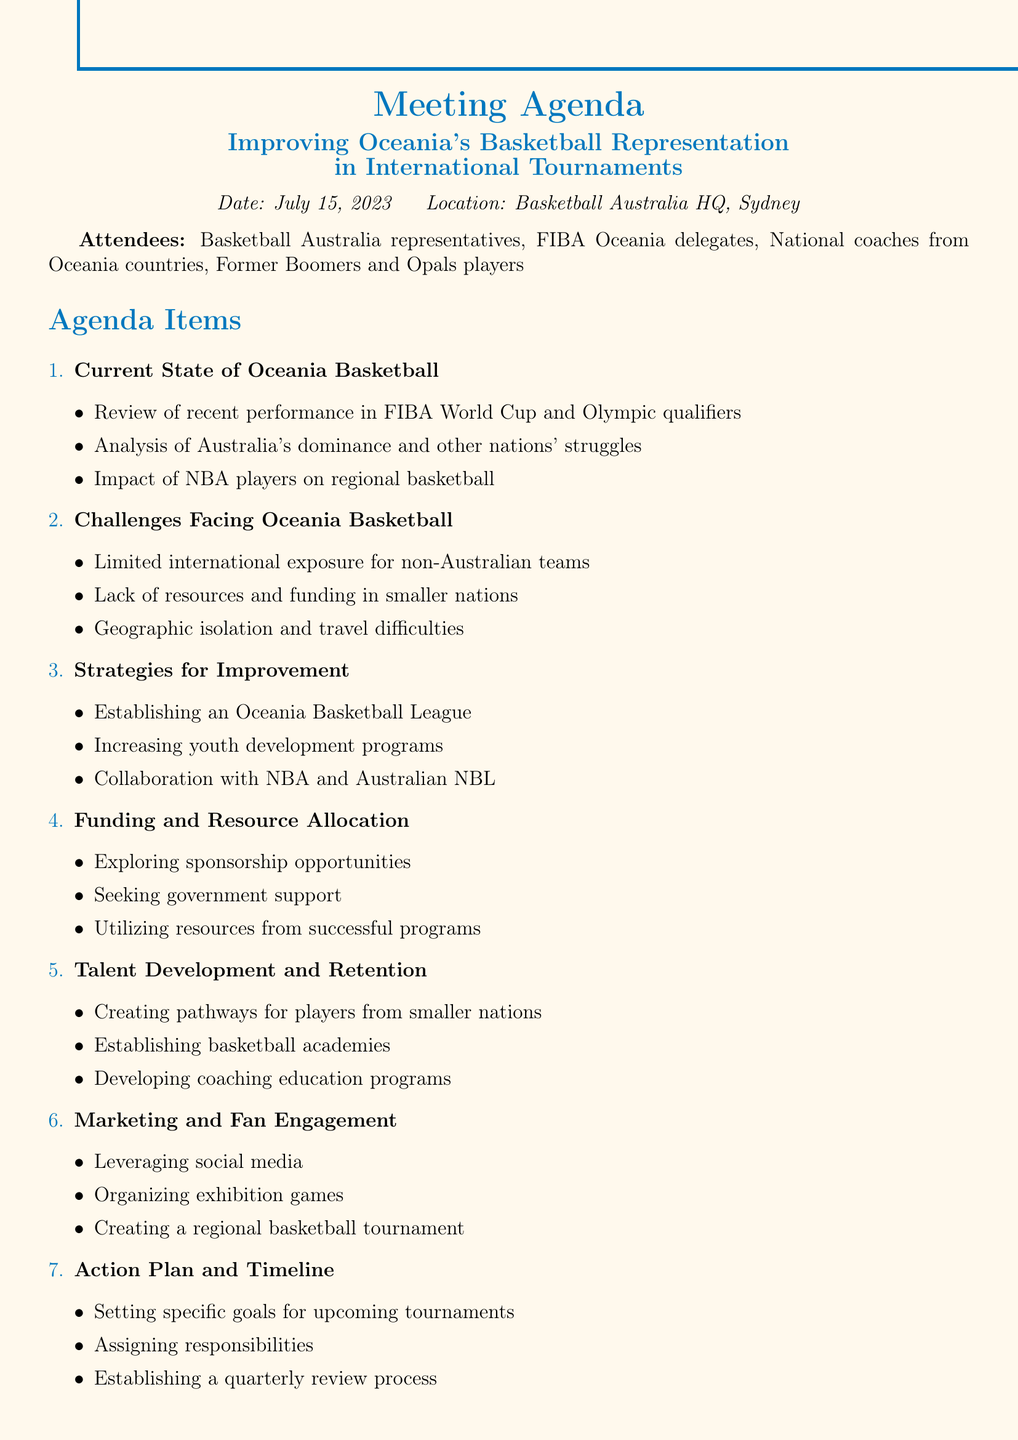What is the date of the meeting? The date of the meeting is explicitly stated in the document.
Answer: July 15, 2023 Who is invited as a guest speaker? The document lists additional notes including a specific guest speaker for the meeting.
Answer: Andrew Bogut What is one of the strategies for improvement mentioned? The agenda item on strategies includes various subtopics that are discussed.
Answer: Establishing an Oceania Basketball League What challenges are faced by Oceania basketball? The challenges facing Oceania basketball are outlined in a specific section of the agenda.
Answer: Limited international exposure for non-Australian teams How many agenda items are listed? The number of agenda items is discerned from the enumeration in the document.
Answer: Seven Which country is mentioned for establishing basketball academies? The document mentions specific countries for talent development initiatives under a dedicated agenda item.
Answer: New Zealand What type of programs are suggested to increase youth development? The document discusses improvements needed for youth programs in a specific agenda item.
Answer: Youth development programs What organization is mentioned in relation to sponsorship opportunities? The funding and resource allocation section refers to specific brands related to sponsorship.
Answer: Spalding and Nike 